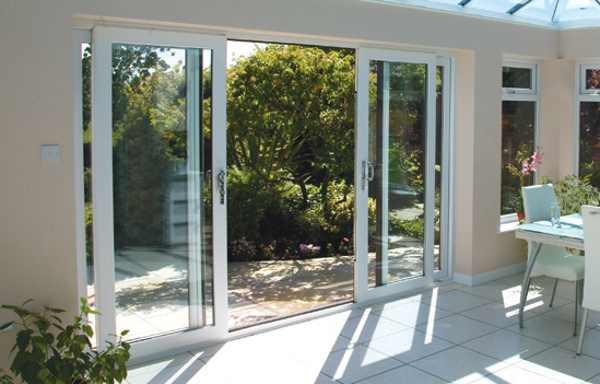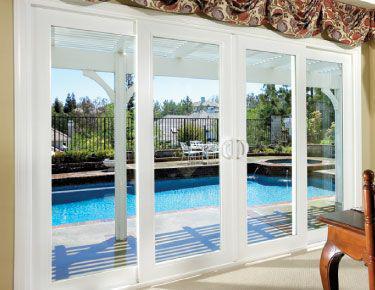The first image is the image on the left, the second image is the image on the right. Evaluate the accuracy of this statement regarding the images: "Two glass doors have white frames surrounding the panes.". Is it true? Answer yes or no. Yes. The first image is the image on the left, the second image is the image on the right. Examine the images to the left and right. Is the description "In at least one image there are four closed tinted windows with white trim." accurate? Answer yes or no. No. 